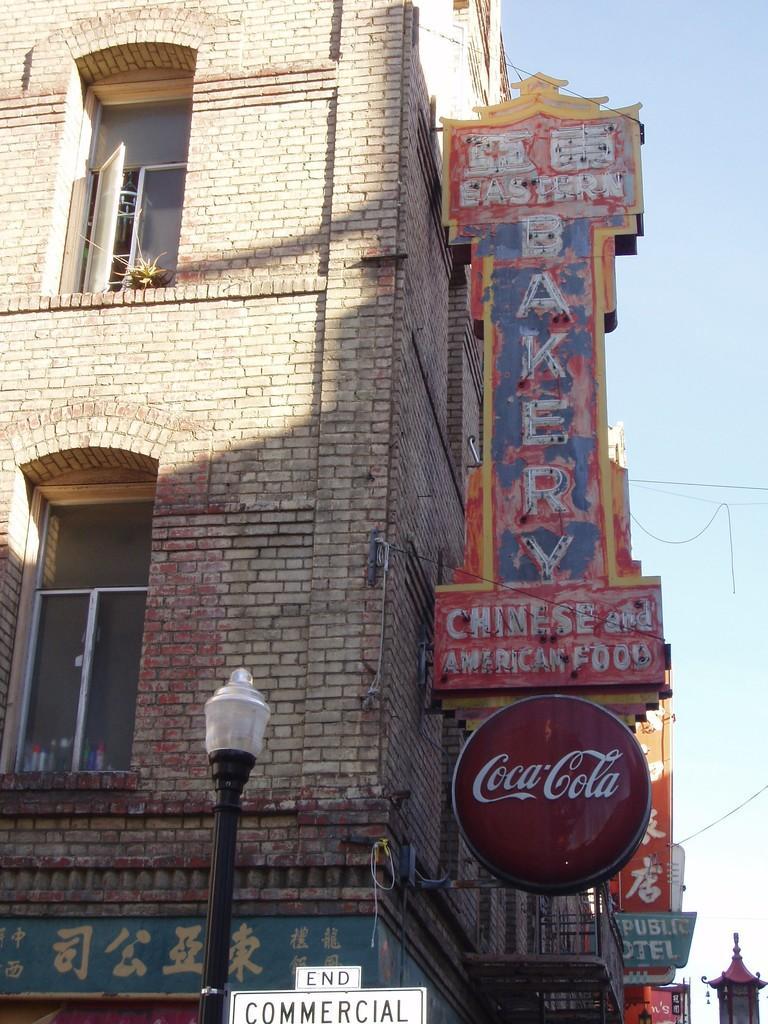Could you give a brief overview of what you see in this image? In this picture there is a building. On the building we can see windows, advertisement boards, posters and banners. At the bottom there is a street light. On the right we can see the electric wires. In the top right there is a sky. 